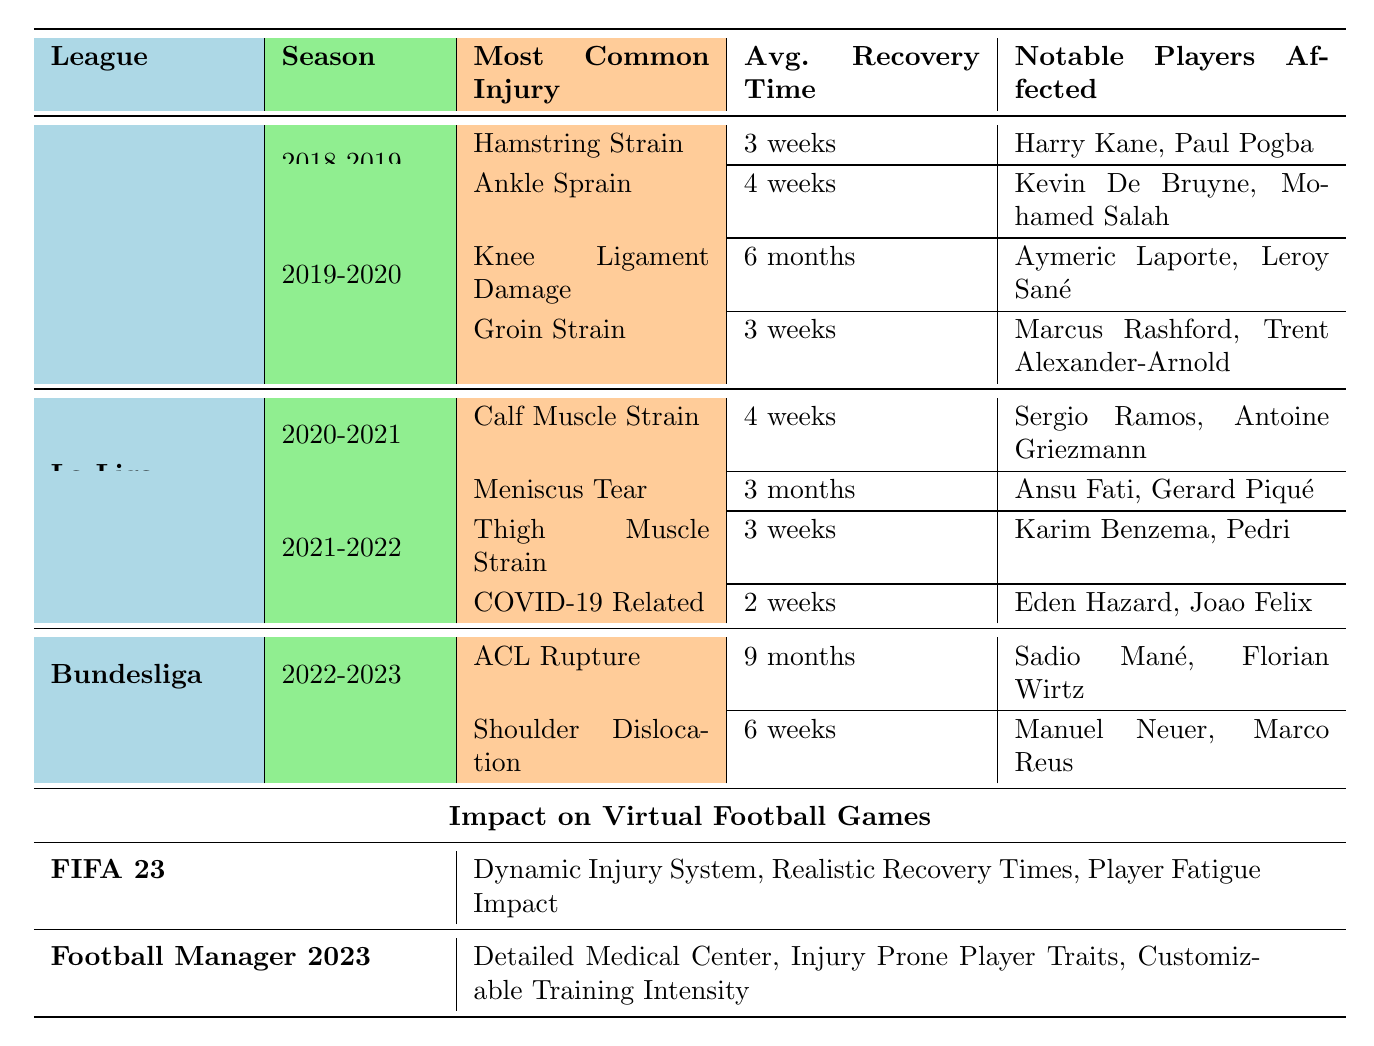What was the average recovery time for players affected by knee ligament damage in the English Premier League? The average recovery time for knee ligament damage based on the data is 6 months, as indicated in the 2019-2020 season table for the English Premier League.
Answer: 6 months Which league had the most common injury of ACL rupture in the last five years? The Bundesliga had the ACL rupture listed as the most common injury during the 2022-2023 season, as stated in the league's injury data.
Answer: Bundesliga How many notable players were affected by calf muscle strain in La Liga during the 2020-2021 season? Two notable players were affected by calf muscle strain: Sergio Ramos and Antoine Griezmann, as reflected in the La Liga injury data for that season.
Answer: 2 Did any player in La Liga for the 2021-2022 season have a recovery time of 2 weeks? Yes, Eden Hazard and Joao Felix were both affected by injuries with an average recovery time of 2 weeks, specifically related to COVID-19, as noted in the La Liga data.
Answer: Yes In which season did groin strain have the same average recovery time as hamstring strain in the English Premier League? Groin strain and hamstring strain both had an average recovery time of 3 weeks during the 2018-2019 season in the English Premier League. This means they were the same in terms of recovery time.
Answer: 2018-2019 What is the total number of notable players affected by injuries in the Bundesliga during the 2022-2023 season? There are four notable players affected by injuries in the Bundesliga: Sadio Mané and Florian Wirtz for ACL rupture, and Manuel Neuer and Marco Reus for shoulder dislocation. Summing these gives us a total of 4 notable players.
Answer: 4 Which player in La Liga had a recovery time longer than 4 weeks due to injury? Ansu Fati had a meniscus tear which had an average recovery time of 3 months, longer than 4 weeks, as shown in the La Liga injury details for the 2020-2021 season.
Answer: Ansu Fati Is the average recovery time for a thigh muscle strain in La Liga shorter than that of a hamstring strain in the English Premier League? Yes, the average recovery time for a thigh muscle strain is 3 weeks while a hamstring strain also has an average recovery time of 3 weeks, thus they are equal. Therefore, the recovery times are not shorter but the same.
Answer: No What notable players affected by injuries had the longest average recovery time in the data? Sadio Mané and Florian Wirtz were affected by ACL ruptures which had the longest average recovery time of 9 months, indicated as the most common injury in the Bundesliga for the 2022-2023 season.
Answer: Sadio Mané, Florian Wirtz How many injuries listed in La Liga for the 2021-2022 season have an average recovery time of less than 4 weeks? In La Liga for the 2021-2022 season, only one injury, COVID-19 related, had an average recovery time of 2 weeks. It is the only injury listed with less than 4 weeks recovery time.
Answer: 1 In FIFA 23, what impact do injuries have on gameplay? The table lists several features such as a dynamic injury system, realistic recovery times, and player fatigue impact, indicating that injuries affect gameplay by simulating real-life injuries in the game.
Answer: Dynamic injury system, realistic recovery times, player fatigue impact 